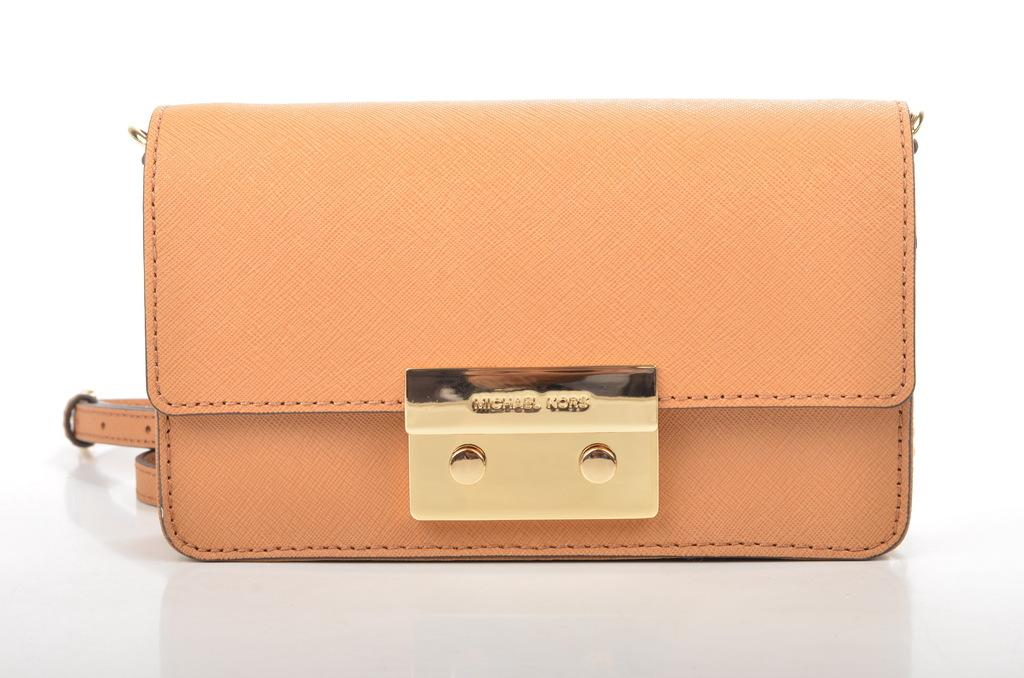What object is in the center of the image? There is a handbag in the center of the image. What is the color of the handbag? The handbag is yellow in color. What type of business is being conducted in the image? There is no indication of any business activity in the image, as it only features a yellow handbag in the center. Can you see a hammer in the image? No, there is no hammer present in the image. 